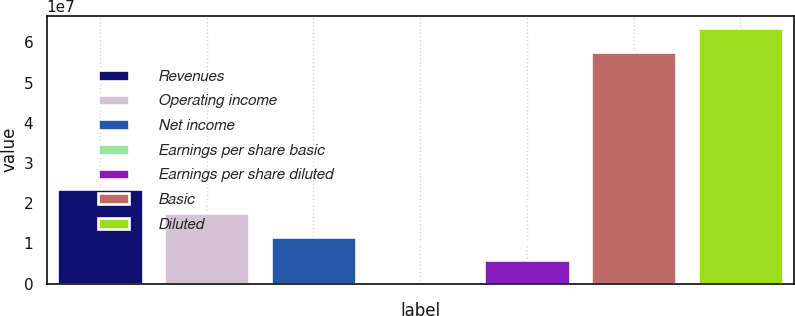Convert chart. <chart><loc_0><loc_0><loc_500><loc_500><bar_chart><fcel>Revenues<fcel>Operating income<fcel>Net income<fcel>Earnings per share basic<fcel>Earnings per share diluted<fcel>Basic<fcel>Diluted<nl><fcel>2.34789e+07<fcel>1.76092e+07<fcel>1.17394e+07<fcel>0.18<fcel>5.86972e+06<fcel>5.75916e+07<fcel>6.34613e+07<nl></chart> 